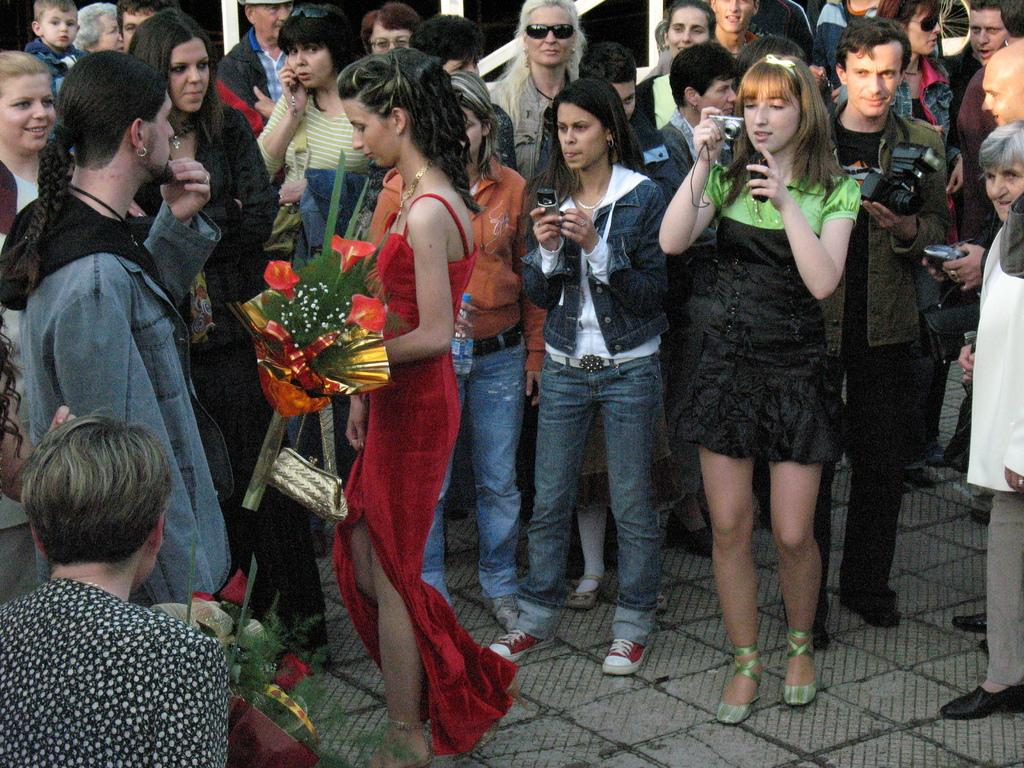What is happening in the image? There are people standing on the land in the image. Can you describe the people in the image? There are both men and women in the image. What are some of the people holding in their hands? Some of the people are holding cameras in their hands. What type of linen is being used to make the crackers in the image? There is no linen or crackers present in the image; it features people standing on the land with some holding cameras. 